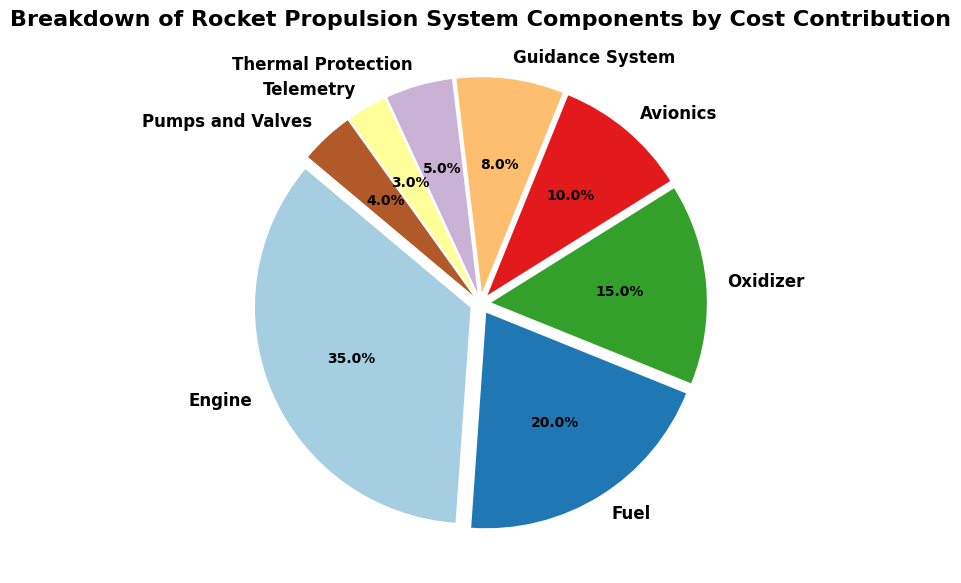Which component has the highest cost contribution? According to the pie chart, the Engine has the highest cost contribution, which is visually represented by the largest slice percentage.
Answer: Engine Which has a higher cost contribution: Thermal Protection or Avionics? Thermal Protection has a cost contribution of 5%, while Avionics has a cost contribution of 10% as shown in the pie chart. Therefore, Avionics has a higher cost contribution.
Answer: Avionics What's the combined cost contribution of the Telemetry and Guidance System? The cost contribution for Telemetry is 3% and for Guidance System is 8%. Adding these together: 3% + 8% = 11%.
Answer: 11% Which component's cost contribution is closest to the average of all components? To find the average cost contribution, sum all percentages and divide by the number of components: (35 + 20 + 15 + 10 + 8 + 5 + 3 + 4) / 8 = 100 / 8 = 12.5%. The component with a cost contribution closest to this average is the Guidance System at 8%.
Answer: Guidance System Is the difference in cost contribution between Fuel and Oxidizer greater than that between Telemetry and Thermal Protection? The difference between Fuel (20%) and Oxidizer (15%) is 5%. The difference between Telemetry (3%) and Thermal Protection (5%) is 2%. Since 5% is greater than 2%, the difference between Fuel and Oxidizer is greater.
Answer: Yes Which two components have the smallest combined cost contribution? The smallest individual components are Telemetry (3%) and Pumps and Valves (4%). Their combined contribution is 3% + 4% = 7%.
Answer: Telemetry and Pumps and Valves What proportion of the total cost contribution is covered by the Engine, Fuel, and Oxidizer combined? The respective cost contributions are Engine (35%), Fuel (20%), and Oxidizer (15%). Combined: 35% + 20% + 15% = 70%.
Answer: 70% Compare the cost contribution of Avionics and Guidance System, which one contributes less and by how much? Avionics contributes 10%, and the Guidance System contributes 8%. The difference is 10% - 8% = 2%. Therefore, the Guidance System contributes 2% less.
Answer: Guidance System, 2% What combination of three components equals the cost contribution of the Engine? The Engine's cost contribution is 35%. Combining Fuel (20%) and Oxidizer (15%) gives exactly 35%.
Answer: Fuel and Oxidizer 